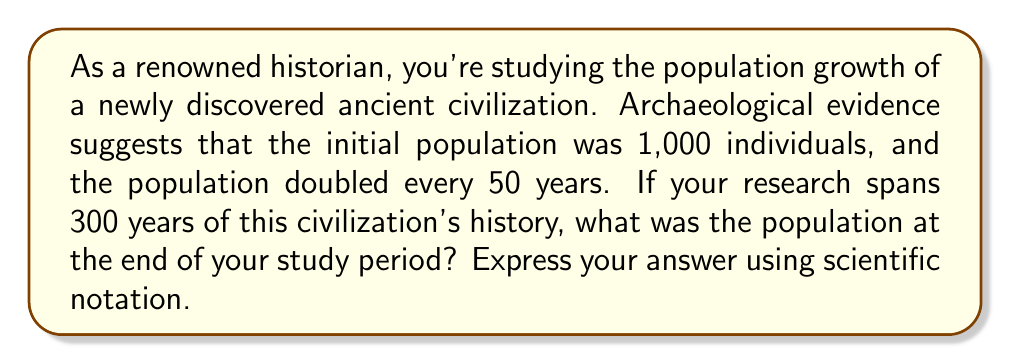Can you solve this math problem? To solve this problem, we'll use the exponential growth function:

$$P(t) = P_0 \cdot (1 + r)^t$$

Where:
$P(t)$ is the population at time $t$
$P_0$ is the initial population
$r$ is the growth rate
$t$ is the time

1. Given information:
   - Initial population, $P_0 = 1,000$
   - Population doubles every 50 years
   - Study period, $t = 300$ years

2. Calculate the growth rate:
   If the population doubles every 50 years, we can set up the equation:
   $$2 = (1 + r)^{50}$$
   
   Taking the 50th root of both sides:
   $$\sqrt[50]{2} = 1 + r$$
   $$r = \sqrt[50]{2} - 1 \approx 0.0139 \text{ or } 1.39\% \text{ per year}$$

3. Calculate the number of doubling periods:
   Number of doubling periods = $\frac{300 \text{ years}}{50 \text{ years}} = 6$

4. Use the exponential growth formula:
   $$P(300) = 1,000 \cdot (1 + 0.0139)^{300}$$
   
   Alternatively, we can use the doubling factor:
   $$P(300) = 1,000 \cdot 2^6 = 1,000 \cdot 64 = 64,000$$

5. Express the result in scientific notation:
   $$64,000 = 6.4 \times 10^4$$
Answer: $6.4 \times 10^4$ 